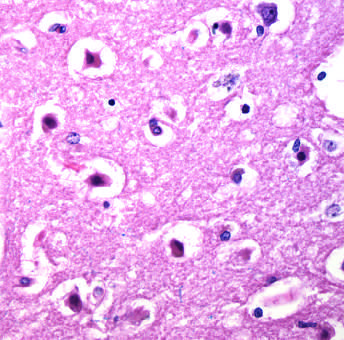re healthy neutrophils with nuclei pyknotic?
Answer the question using a single word or phrase. No 